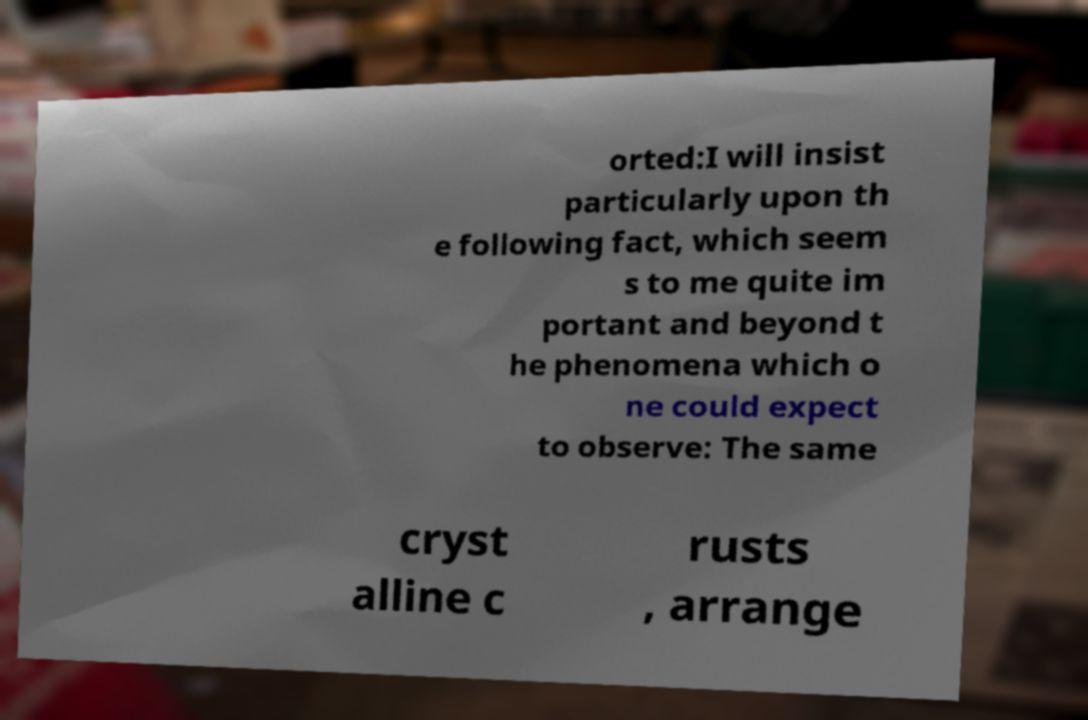There's text embedded in this image that I need extracted. Can you transcribe it verbatim? orted:I will insist particularly upon th e following fact, which seem s to me quite im portant and beyond t he phenomena which o ne could expect to observe: The same cryst alline c rusts , arrange 